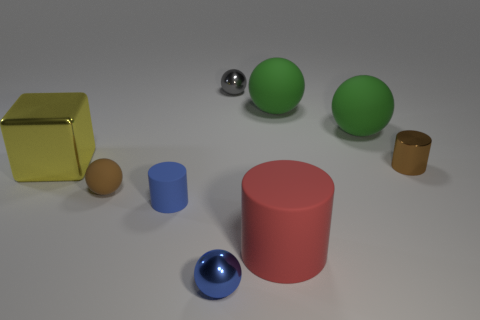What could be the possible use of these objects in a real-world setting? The objects could have various uses in a real-world setting. The large yellow cube could be a storage container, the spheres could be decorative elements or toys, the blue and brown cylinders might be containers or stands, and the red cylinder could serve as a base for a table or a display pedestal. The small brown rubber object could be an eraser, and the metallic sphere might be a decorative knob or a part of a larger machine. 